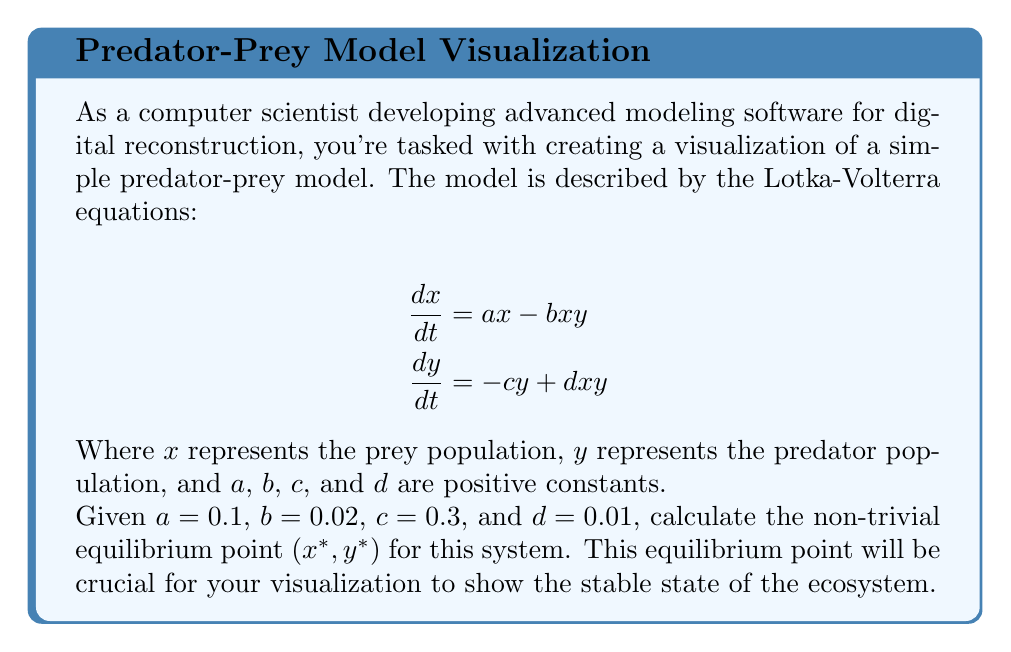Provide a solution to this math problem. To find the non-trivial equilibrium point, we need to set both equations equal to zero and solve for $x$ and $y$:

1) Set $\frac{dx}{dt} = 0$:
   $$0 = ax - bxy$$
   $$ax = bxy$$
   $$x(a - by) = 0$$
   
   Since we want the non-trivial solution, $x \neq 0$, so:
   $$a - by = 0$$
   $$y = \frac{a}{b} = \frac{0.1}{0.02} = 5$$

2) Set $\frac{dy}{dt} = 0$:
   $$0 = -cy + dxy$$
   $$cy = dxy$$
   $$y(c - dx) = 0$$
   
   Since we want the non-trivial solution, $y \neq 0$, so:
   $$c - dx = 0$$
   $$x = \frac{c}{d} = \frac{0.3}{0.01} = 30$$

3) Therefore, the non-trivial equilibrium point $(x^*, y^*)$ is $(30, 5)$.

This point represents the stable state where the prey and predator populations remain constant over time in your model visualization.
Answer: $(30, 5)$ 